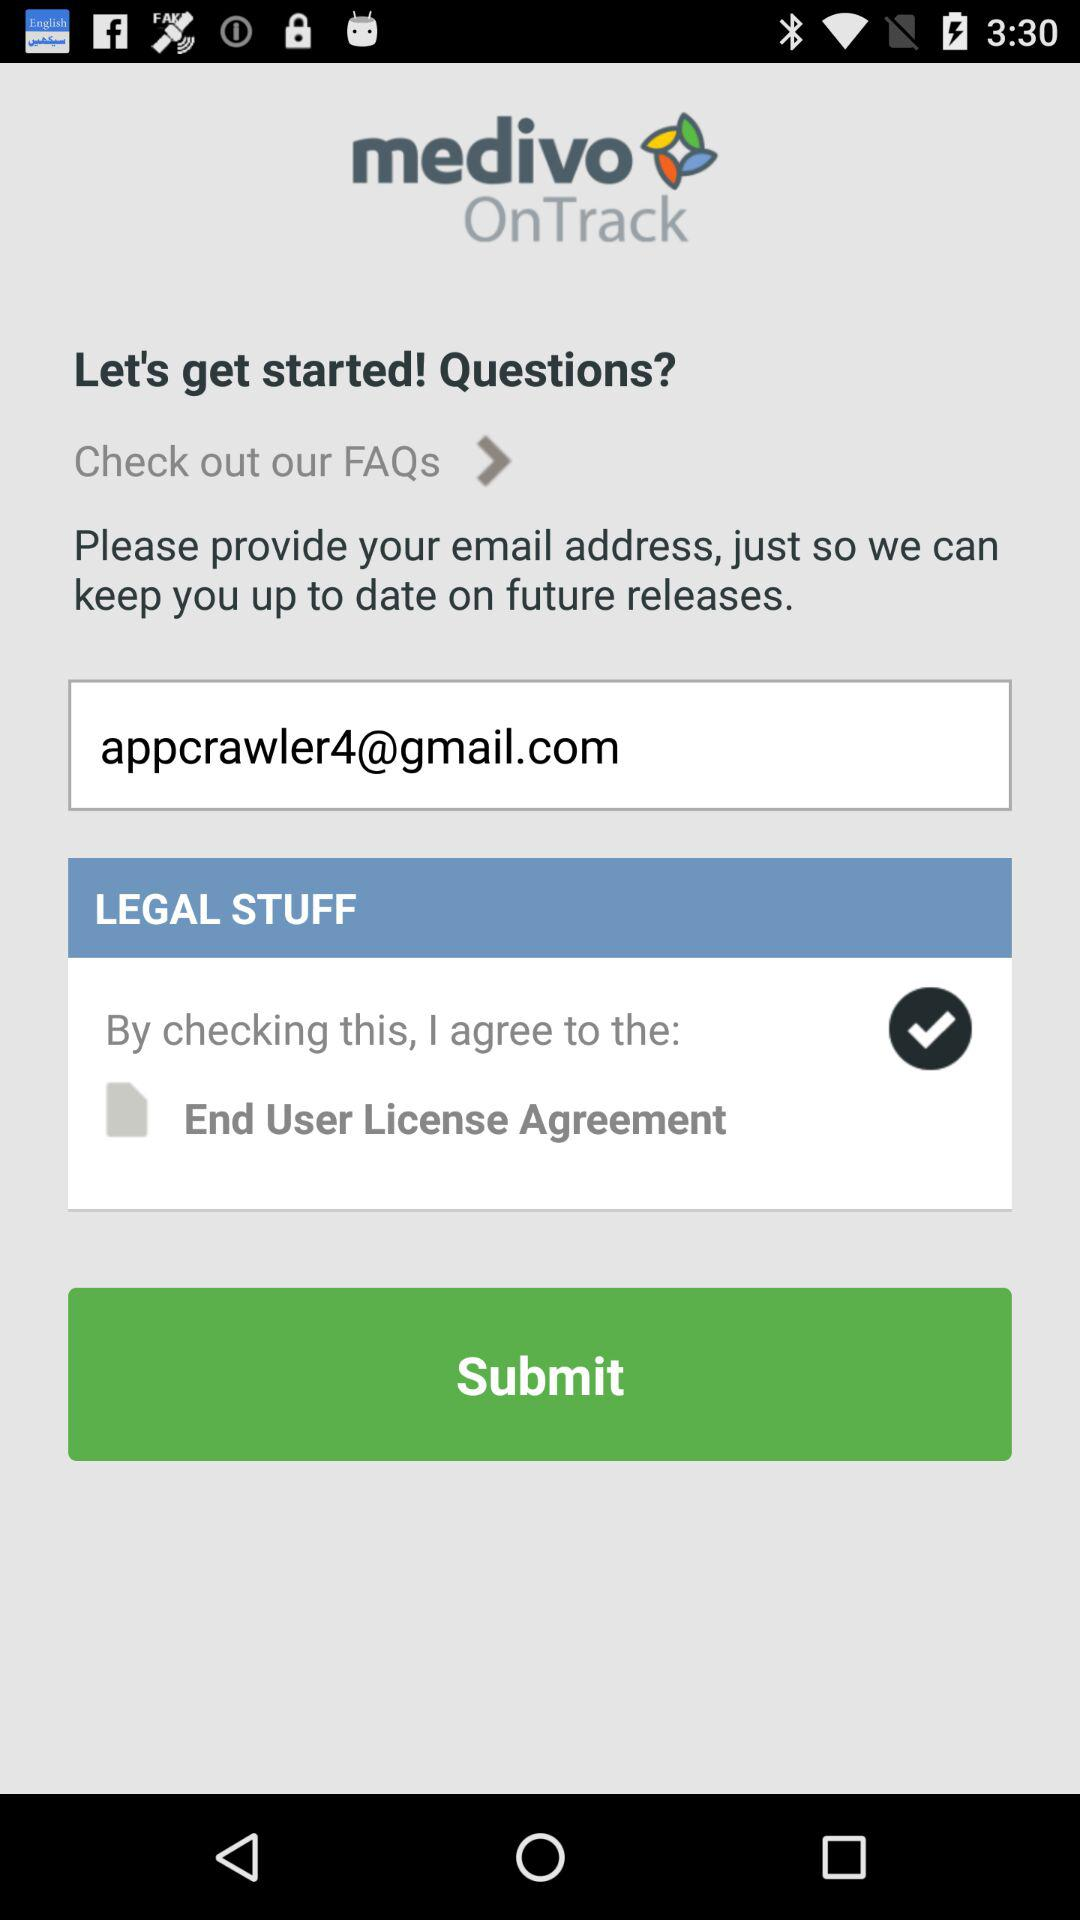What is the email address? The email address is "appcrawler4@gmail.com". 